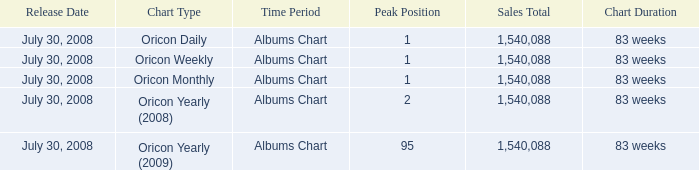Would you be able to parse every entry in this table? {'header': ['Release Date', 'Chart Type', 'Time Period', 'Peak Position', 'Sales Total', 'Chart Duration'], 'rows': [['July 30, 2008', 'Oricon Daily', 'Albums Chart', '1', '1,540,088', '83 weeks'], ['July 30, 2008', 'Oricon Weekly', 'Albums Chart', '1', '1,540,088', '83 weeks'], ['July 30, 2008', 'Oricon Monthly', 'Albums Chart', '1', '1,540,088', '83 weeks'], ['July 30, 2008', 'Oricon Yearly (2008)', 'Albums Chart', '2', '1,540,088', '83 weeks'], ['July 30, 2008', 'Oricon Yearly (2009)', 'Albums Chart', '95', '1,540,088', '83 weeks']]} Which Sales Total has a Chart of oricon monthly albums chart? 1540088.0. 